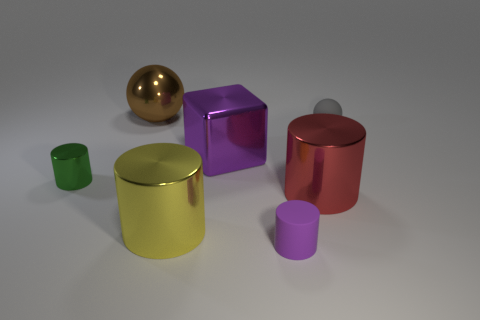Subtract 1 cylinders. How many cylinders are left? 3 Add 2 big brown rubber things. How many objects exist? 9 Subtract all spheres. How many objects are left? 5 Add 7 green shiny things. How many green shiny things are left? 8 Add 6 yellow metal things. How many yellow metal things exist? 7 Subtract 0 brown blocks. How many objects are left? 7 Subtract all green cylinders. Subtract all red shiny cylinders. How many objects are left? 5 